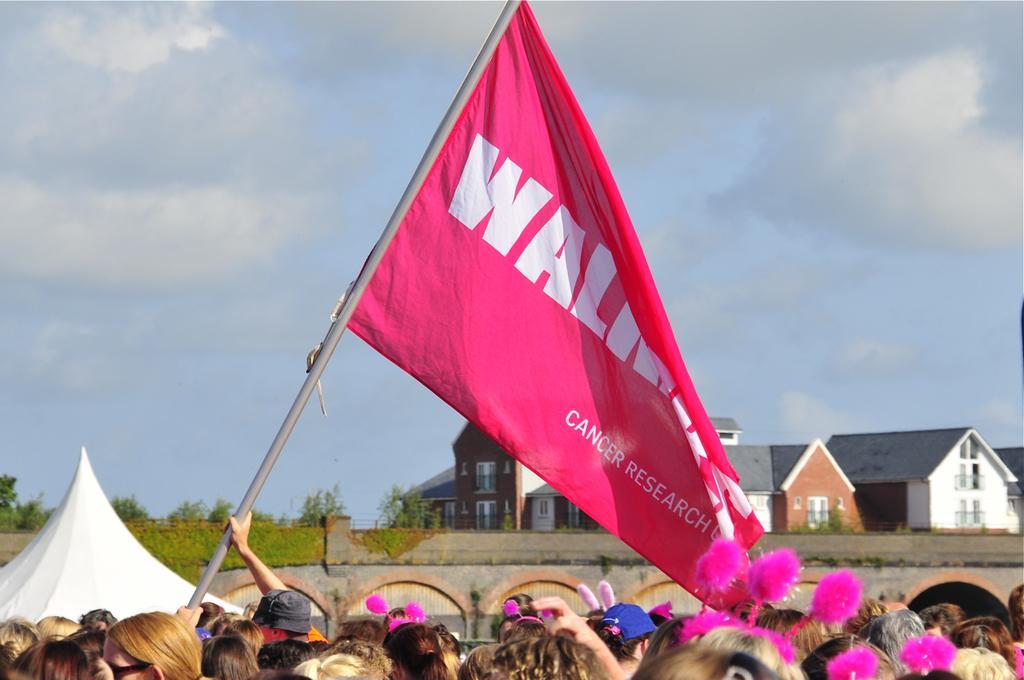Can you describe this image briefly? In this picture there are group of people those who are standing at the bottom side of the image, by holding a flag in there hands, there is a tent on the left side of the image and there are houses and plants in the background area of the image. 